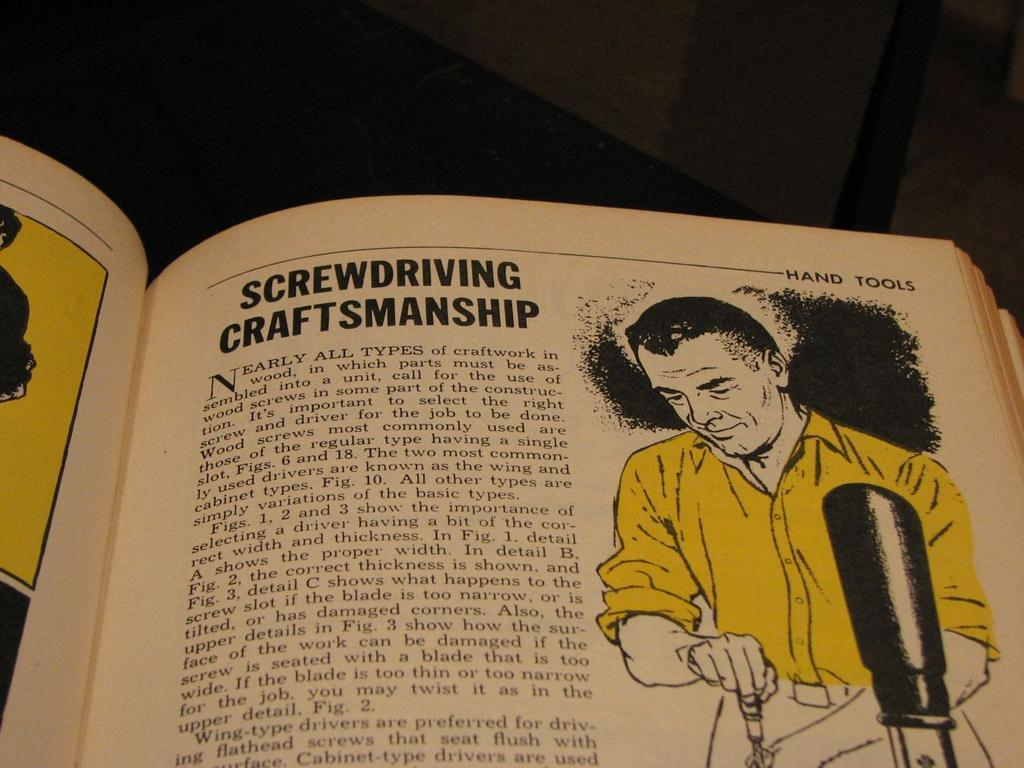<image>
Offer a succinct explanation of the picture presented. Page showing a man wearing a yellow shirt and titled "Screwdriving Craftsmanship". 